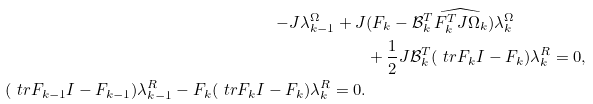Convert formula to latex. <formula><loc_0><loc_0><loc_500><loc_500>- J \lambda ^ { \Omega } _ { k - 1 } + J & ( F _ { k } - \mathcal { B } _ { k } ^ { T } \widehat { F _ { k } ^ { T } J \Omega _ { k } } ) \lambda _ { k } ^ { \Omega } \\ & + \frac { 1 } { 2 } J \mathcal { B } _ { k } ^ { T } ( \ t r { F _ { k } } I - F _ { k } ) \lambda _ { k } ^ { R } = 0 , \\ ( \ t r { F _ { k - 1 } } I - F _ { k - 1 } ) \lambda _ { k - 1 } ^ { R } - F _ { k } ( \ t r { F _ { k } } I - F _ { k } ) \lambda _ { k } ^ { R } = 0 .</formula> 